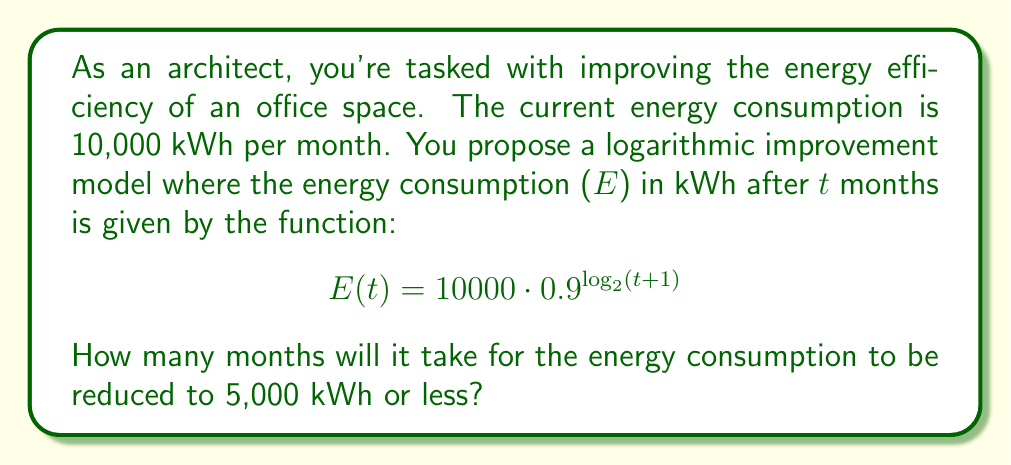Show me your answer to this math problem. Let's approach this step-by-step:

1) We want to find t when E(t) ≤ 5000. So, we need to solve:

   $$5000 \geq 10000 \cdot 0.9^{\log_2(t+1)}$$

2) Dividing both sides by 10000:

   $$0.5 \geq 0.9^{\log_2(t+1)}$$

3) Taking the logarithm (base 0.9) of both sides:

   $$\log_{0.9}(0.5) \leq \log_2(t+1)$$

4) Using the change of base formula:

   $$\frac{\ln(0.5)}{\ln(0.9)} \leq \log_2(t+1)$$

5) Calculating the left side:

   $$6.5776... \leq \log_2(t+1)$$

6) Now, we can apply 2^ to both sides:

   $$2^{6.5776...} \leq t+1$$

7) Simplifying:

   $$95.6834... \leq t+1$$

8) Subtracting 1 from both sides:

   $$94.6834... \leq t$$

9) Since t represents months, we need to round up to the nearest whole number:

   $$t \geq 95$$

Therefore, it will take 95 months for the energy consumption to be reduced to 5,000 kWh or less.
Answer: 95 months 